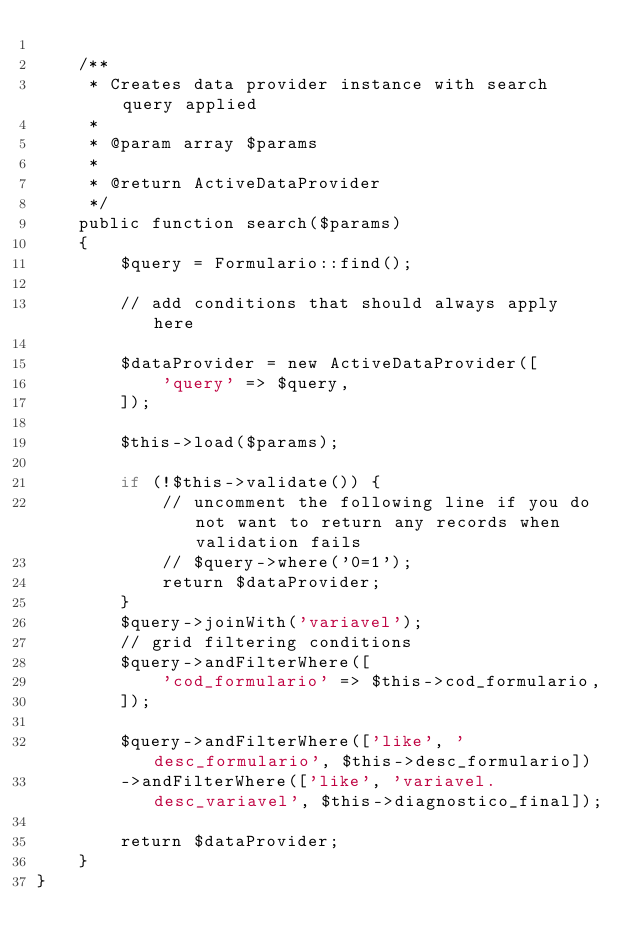<code> <loc_0><loc_0><loc_500><loc_500><_PHP_>
    /**
     * Creates data provider instance with search query applied
     *
     * @param array $params
     *
     * @return ActiveDataProvider
     */
    public function search($params)
    {
        $query = Formulario::find();

        // add conditions that should always apply here

        $dataProvider = new ActiveDataProvider([
            'query' => $query,
        ]);

        $this->load($params);

        if (!$this->validate()) {
            // uncomment the following line if you do not want to return any records when validation fails
            // $query->where('0=1');
            return $dataProvider;
        }
        $query->joinWith('variavel');
        // grid filtering conditions
        $query->andFilterWhere([
            'cod_formulario' => $this->cod_formulario,
        ]);

        $query->andFilterWhere(['like', 'desc_formulario', $this->desc_formulario])
        ->andFilterWhere(['like', 'variavel.desc_variavel', $this->diagnostico_final]);

        return $dataProvider;
    }
}
</code> 